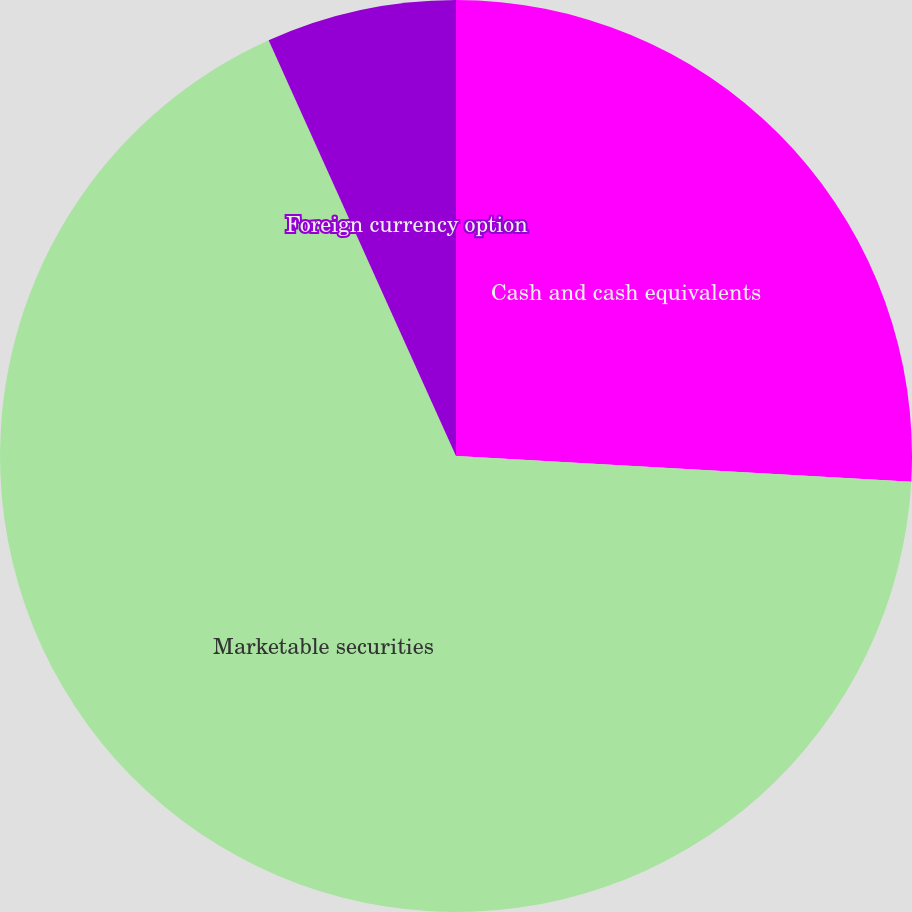Convert chart to OTSL. <chart><loc_0><loc_0><loc_500><loc_500><pie_chart><fcel>Cash and cash equivalents<fcel>Marketable securities<fcel>Forward foreign currency<fcel>Foreign currency option<nl><fcel>25.9%<fcel>67.36%<fcel>0.0%<fcel>6.74%<nl></chart> 